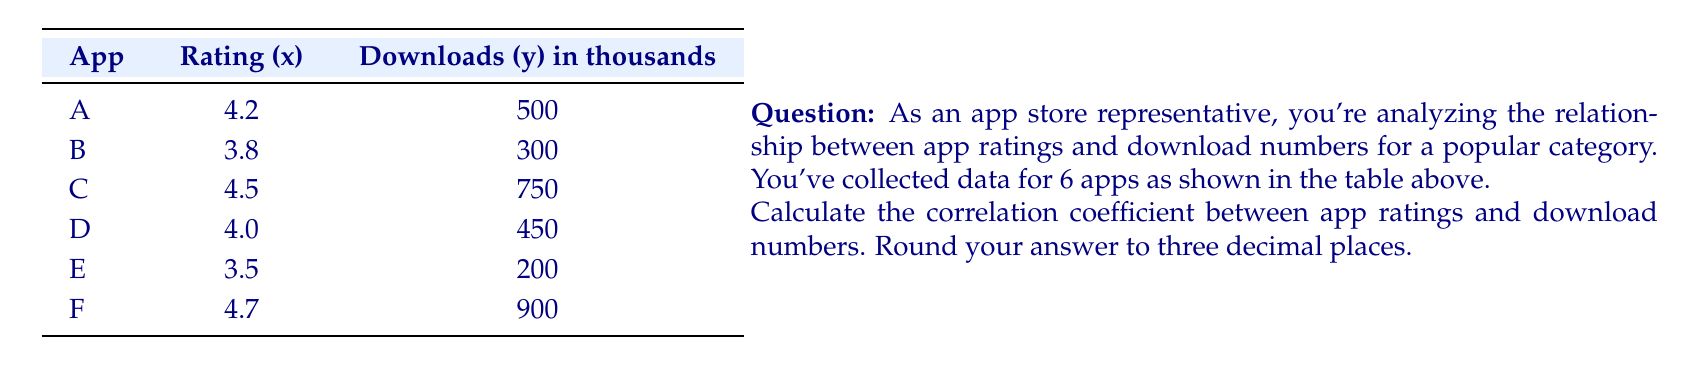Can you answer this question? To calculate the correlation coefficient, we'll use the formula:

$$ r = \frac{n\sum xy - (\sum x)(\sum y)}{\sqrt{[n\sum x^2 - (\sum x)^2][n\sum y^2 - (\sum y)^2]}} $$

Where:
$n$ = number of pairs
$x$ = app ratings
$y$ = download numbers (in thousands)

Step 1: Calculate the necessary sums:
$n = 6$
$\sum x = 4.2 + 3.8 + 4.5 + 4.0 + 3.5 + 4.7 = 24.7$
$\sum y = 500 + 300 + 750 + 450 + 200 + 900 = 3100$
$\sum xy = (4.2 \times 500) + (3.8 \times 300) + ... + (4.7 \times 900) = 13960$
$\sum x^2 = 4.2^2 + 3.8^2 + ... + 4.7^2 = 102.43$
$\sum y^2 = 500^2 + 300^2 + ... + 900^2 = 2,265,000$

Step 2: Apply the formula:

$$ r = \frac{6(13960) - (24.7)(3100)}{\sqrt{[6(102.43) - 24.7^2][6(2265000) - 3100^2]}} $$

Step 3: Simplify:

$$ r = \frac{83760 - 76570}{\sqrt{(614.58 - 610.09)(13590000 - 9610000)}} $$

$$ r = \frac{7190}{\sqrt{4.49 \times 3980000}} $$

$$ r = \frac{7190}{\sqrt{17860200}} $$

$$ r = \frac{7190}{4225.64} $$

$$ r = 0.9560 $$

Step 4: Round to three decimal places:
$r = 0.956$
Answer: 0.956 